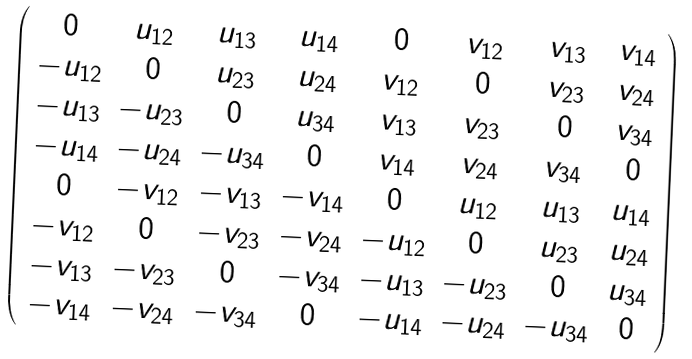Convert formula to latex. <formula><loc_0><loc_0><loc_500><loc_500>\left ( \begin{array} { c c c c c c c c } 0 & u _ { 1 2 } & u _ { 1 3 } & u _ { 1 4 } & 0 & v _ { 1 2 } & v _ { 1 3 } & v _ { 1 4 } \\ - u _ { 1 2 } & 0 & u _ { 2 3 } & u _ { 2 4 } & v _ { 1 2 } & 0 & v _ { 2 3 } & v _ { 2 4 } \\ - u _ { 1 3 } & - u _ { 2 3 } & 0 & u _ { 3 4 } & v _ { 1 3 } & v _ { 2 3 } & 0 & v _ { 3 4 } \\ - u _ { 1 4 } & - u _ { 2 4 } & - u _ { 3 4 } & 0 & v _ { 1 4 } & v _ { 2 4 } & v _ { 3 4 } & 0 \\ 0 & - v _ { 1 2 } & - v _ { 1 3 } & - v _ { 1 4 } & 0 & u _ { 1 2 } & u _ { 1 3 } & u _ { 1 4 } \\ - v _ { 1 2 } & 0 & - v _ { 2 3 } & - v _ { 2 4 } & - u _ { 1 2 } & 0 & u _ { 2 3 } & u _ { 2 4 } \\ - v _ { 1 3 } & - v _ { 2 3 } & 0 & - v _ { 3 4 } & - u _ { 1 3 } & - u _ { 2 3 } & 0 & u _ { 3 4 } \\ - v _ { 1 4 } & - v _ { 2 4 } & - v _ { 3 4 } & 0 & - u _ { 1 4 } & - u _ { 2 4 } & - u _ { 3 4 } & 0 \\ \end{array} \right )</formula> 